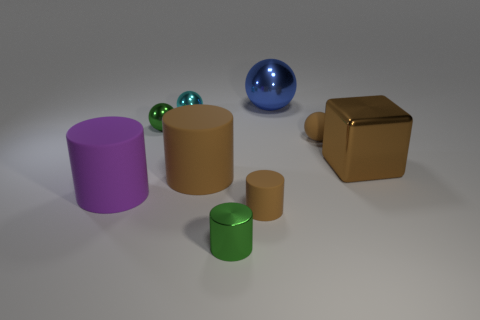Add 1 tiny yellow balls. How many objects exist? 10 Subtract all spheres. How many objects are left? 5 Add 8 purple cylinders. How many purple cylinders exist? 9 Subtract 1 cyan spheres. How many objects are left? 8 Subtract all tiny purple cubes. Subtract all tiny rubber things. How many objects are left? 7 Add 1 large purple things. How many large purple things are left? 2 